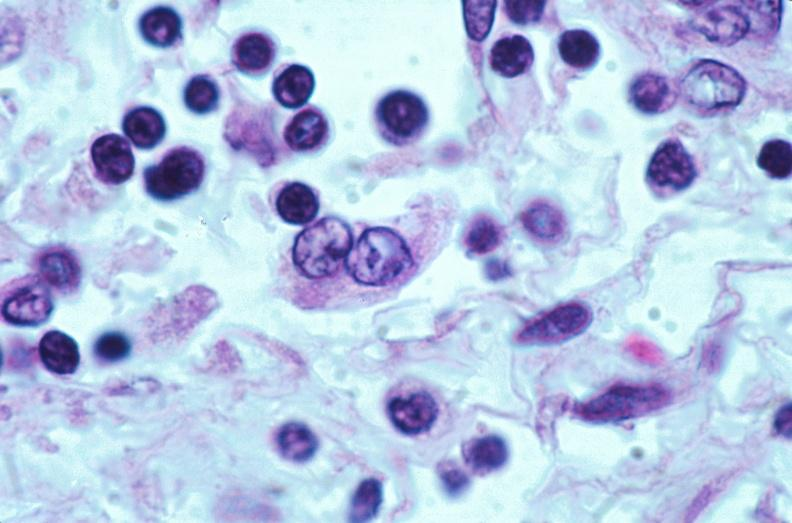does retroperitoneum show lymph nodes, nodular sclerosing hodgkins disease?
Answer the question using a single word or phrase. No 